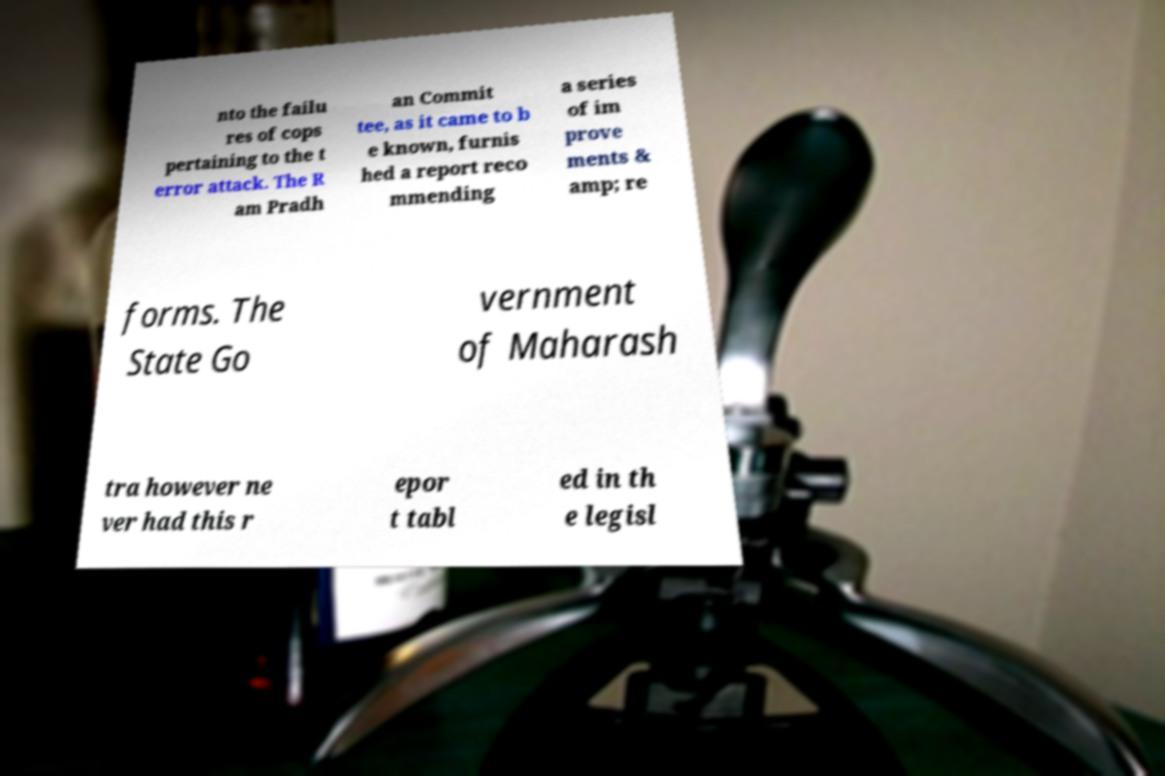Please read and relay the text visible in this image. What does it say? nto the failu res of cops pertaining to the t error attack. The R am Pradh an Commit tee, as it came to b e known, furnis hed a report reco mmending a series of im prove ments & amp; re forms. The State Go vernment of Maharash tra however ne ver had this r epor t tabl ed in th e legisl 